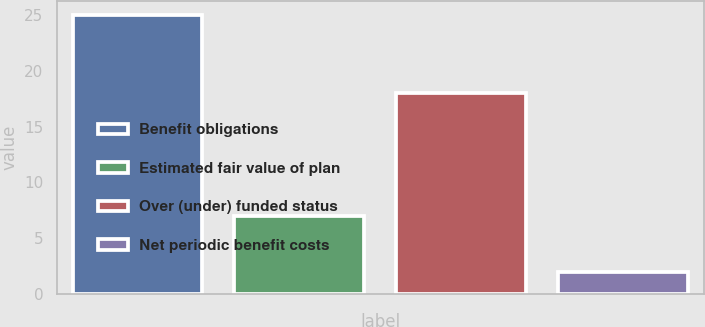<chart> <loc_0><loc_0><loc_500><loc_500><bar_chart><fcel>Benefit obligations<fcel>Estimated fair value of plan<fcel>Over (under) funded status<fcel>Net periodic benefit costs<nl><fcel>25<fcel>7<fcel>18<fcel>2<nl></chart> 